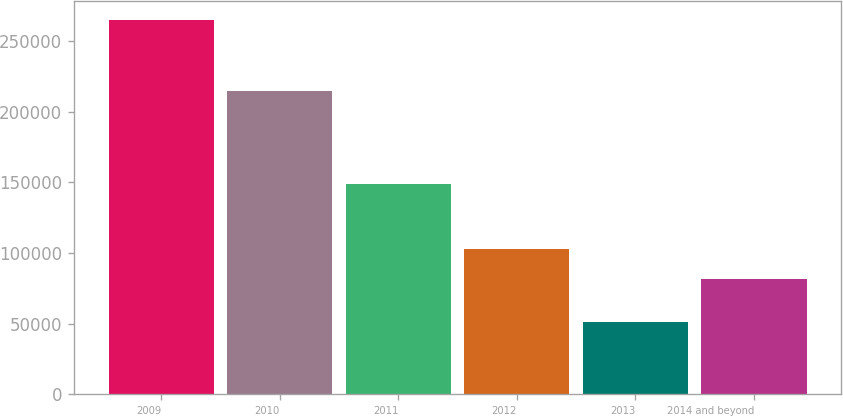<chart> <loc_0><loc_0><loc_500><loc_500><bar_chart><fcel>2009<fcel>2010<fcel>2011<fcel>2012<fcel>2013<fcel>2014 and beyond<nl><fcel>265130<fcel>215081<fcel>149252<fcel>102863<fcel>51207<fcel>81471<nl></chart> 